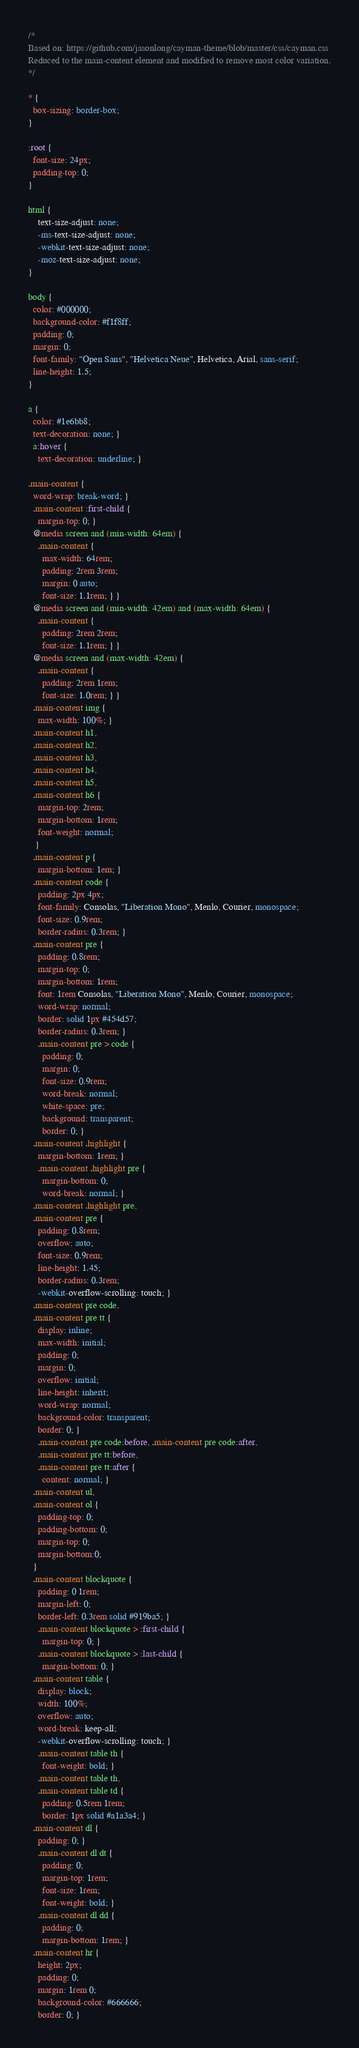<code> <loc_0><loc_0><loc_500><loc_500><_CSS_>/*
Based on: https://github.com/jasonlong/cayman-theme/blob/master/css/cayman.css
Reduced to the main-content element and modified to remove most color variation.
*/

* {
  box-sizing: border-box;
}

:root {
  font-size: 24px;
  padding-top: 0;
}

html {
    text-size-adjust: none;
    -ms-text-size-adjust: none;
    -webkit-text-size-adjust: none;
    -moz-text-size-adjust: none;
}

body {
  color: #000000;
  background-color: #f1f8ff;
  padding: 0;
  margin: 0;
  font-family: "Open Sans", "Helvetica Neue", Helvetica, Arial, sans-serif;
  line-height: 1.5;
}

a {
  color: #1e6bb8;
  text-decoration: none; }
  a:hover {
    text-decoration: underline; }

.main-content {
  word-wrap: break-word; }
  .main-content :first-child {
    margin-top: 0; }
  @media screen and (min-width: 64em) {
    .main-content {
      max-width: 64rem;
      padding: 2rem 3rem;
      margin: 0 auto;
      font-size: 1.1rem; } }
  @media screen and (min-width: 42em) and (max-width: 64em) {
    .main-content {
      padding: 2rem 2rem;
      font-size: 1.1rem; } }
  @media screen and (max-width: 42em) {
    .main-content {
      padding: 2rem 1rem;
      font-size: 1.0rem; } }
  .main-content img {
    max-width: 100%; }
  .main-content h1,
  .main-content h2,
  .main-content h3,
  .main-content h4,
  .main-content h5,
  .main-content h6 {
    margin-top: 2rem;
    margin-bottom: 1rem;
    font-weight: normal;
   }
  .main-content p {
    margin-bottom: 1em; }
  .main-content code {
    padding: 2px 4px;
    font-family: Consolas, "Liberation Mono", Menlo, Courier, monospace;
    font-size: 0.9rem;
    border-radius: 0.3rem; }
  .main-content pre {
    padding: 0.8rem;
    margin-top: 0;
    margin-bottom: 1rem;
    font: 1rem Consolas, "Liberation Mono", Menlo, Courier, monospace;
    word-wrap: normal;
    border: solid 1px #454d57;
    border-radius: 0.3rem; }
    .main-content pre > code {
      padding: 0;
      margin: 0;
      font-size: 0.9rem;
      word-break: normal;
      white-space: pre;
      background: transparent;
      border: 0; }
  .main-content .highlight {
    margin-bottom: 1rem; }
    .main-content .highlight pre {
      margin-bottom: 0;
      word-break: normal; }
  .main-content .highlight pre,
  .main-content pre {
    padding: 0.8rem;
    overflow: auto;
    font-size: 0.9rem;
    line-height: 1.45;
    border-radius: 0.3rem;
    -webkit-overflow-scrolling: touch; }
  .main-content pre code,
  .main-content pre tt {
    display: inline;
    max-width: initial;
    padding: 0;
    margin: 0;
    overflow: initial;
    line-height: inherit;
    word-wrap: normal;
    background-color: transparent;
    border: 0; }
    .main-content pre code:before, .main-content pre code:after,
    .main-content pre tt:before,
    .main-content pre tt:after {
      content: normal; }
  .main-content ul,
  .main-content ol {
    padding-top: 0;
    padding-bottom: 0;
    margin-top: 0;
    margin-bottom:0;
  }
  .main-content blockquote {
    padding: 0 1rem;
    margin-left: 0;
    border-left: 0.3rem solid #919ba5; }
    .main-content blockquote > :first-child {
      margin-top: 0; }
    .main-content blockquote > :last-child {
      margin-bottom: 0; }
  .main-content table {
    display: block;
    width: 100%;
    overflow: auto;
    word-break: keep-all;
    -webkit-overflow-scrolling: touch; }
    .main-content table th {
      font-weight: bold; }
    .main-content table th,
    .main-content table td {
      padding: 0.5rem 1rem;
      border: 1px solid #a1a3a4; }
  .main-content dl {
    padding: 0; }
    .main-content dl dt {
      padding: 0;
      margin-top: 1rem;
      font-size: 1rem;
      font-weight: bold; }
    .main-content dl dd {
      padding: 0;
      margin-bottom: 1rem; }
  .main-content hr {
    height: 2px;
    padding: 0;
    margin: 1rem 0;
    background-color: #666666;
    border: 0; }
</code> 